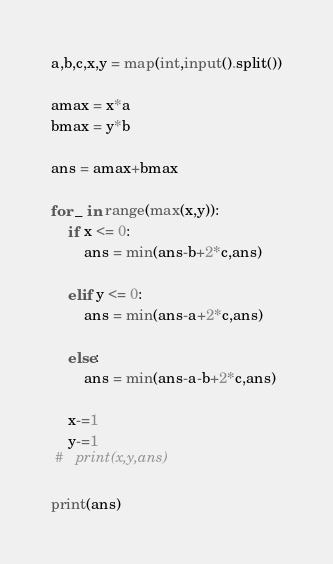Convert code to text. <code><loc_0><loc_0><loc_500><loc_500><_Python_>a,b,c,x,y = map(int,input().split())

amax = x*a
bmax = y*b

ans = amax+bmax

for _ in range(max(x,y)):
    if x <= 0:
        ans = min(ans-b+2*c,ans)

    elif y <= 0:
        ans = min(ans-a+2*c,ans)

    else:
        ans = min(ans-a-b+2*c,ans)
        
    x-=1
    y-=1
 #   print(x,y,ans)

print(ans)</code> 